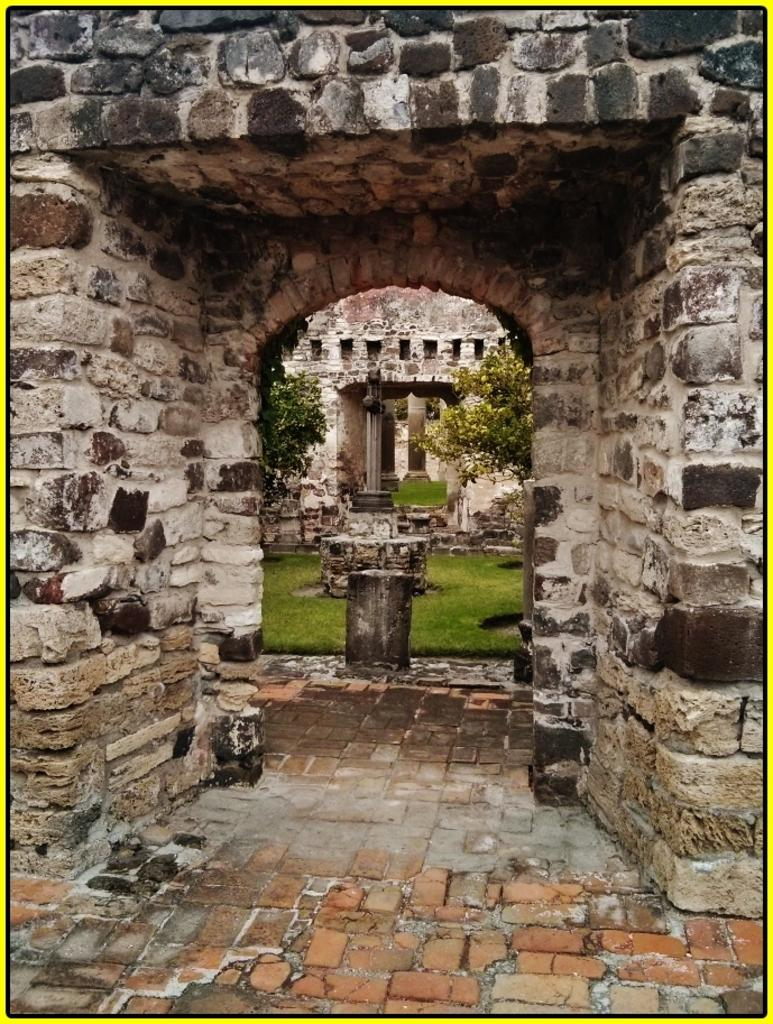What type of vegetation is present in the image? There is grass in the image. What type of structure can be seen in the image? There is a wall in the image. What other natural elements are visible in the image? There are trees in the image. What architectural features can be observed in the image? There are pillars in the image. Can you hear the ants laughing in the image? There are no ants or sounds present in the image, so it is not possible to hear them laughing. 